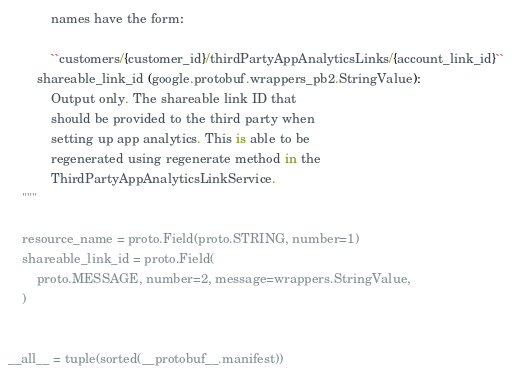Convert code to text. <code><loc_0><loc_0><loc_500><loc_500><_Python_>            names have the form:

            ``customers/{customer_id}/thirdPartyAppAnalyticsLinks/{account_link_id}``
        shareable_link_id (google.protobuf.wrappers_pb2.StringValue):
            Output only. The shareable link ID that
            should be provided to the third party when
            setting up app analytics. This is able to be
            regenerated using regenerate method in the
            ThirdPartyAppAnalyticsLinkService.
    """

    resource_name = proto.Field(proto.STRING, number=1)
    shareable_link_id = proto.Field(
        proto.MESSAGE, number=2, message=wrappers.StringValue,
    )


__all__ = tuple(sorted(__protobuf__.manifest))
</code> 